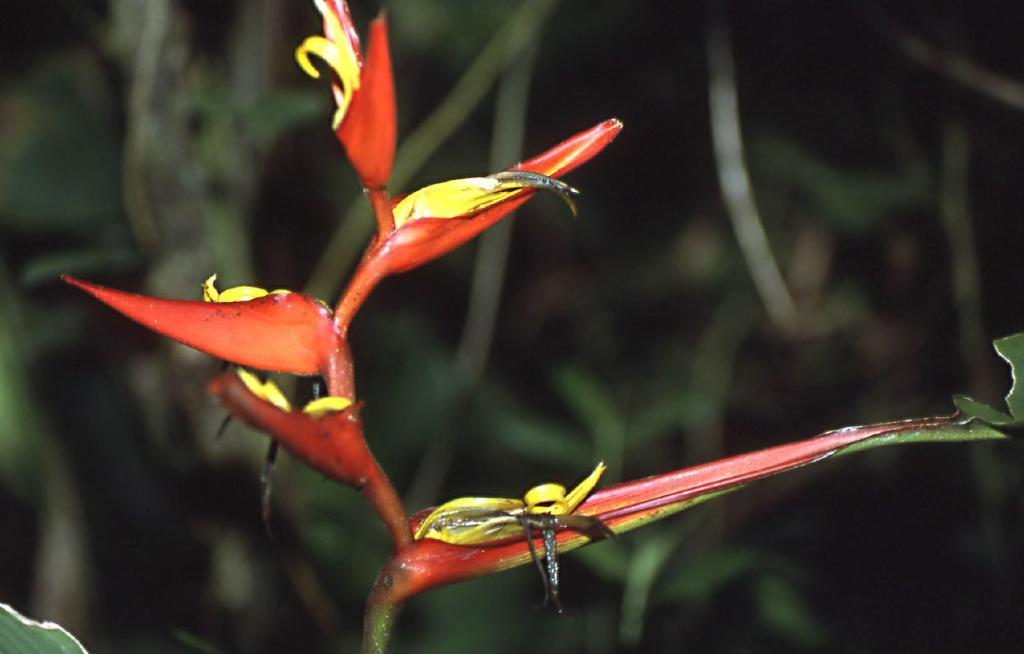What is the main subject of the image? There is a flower in the image. Can you describe the background of the image? The background of the image is blurred. What type of pot is the flower growing in within the image? There is no pot present in the image; the flower is not shown growing in a pot. Can you describe how the knee is positioned in the image? There is no knee present in the image; the focus is on the flower and the blurred background. 